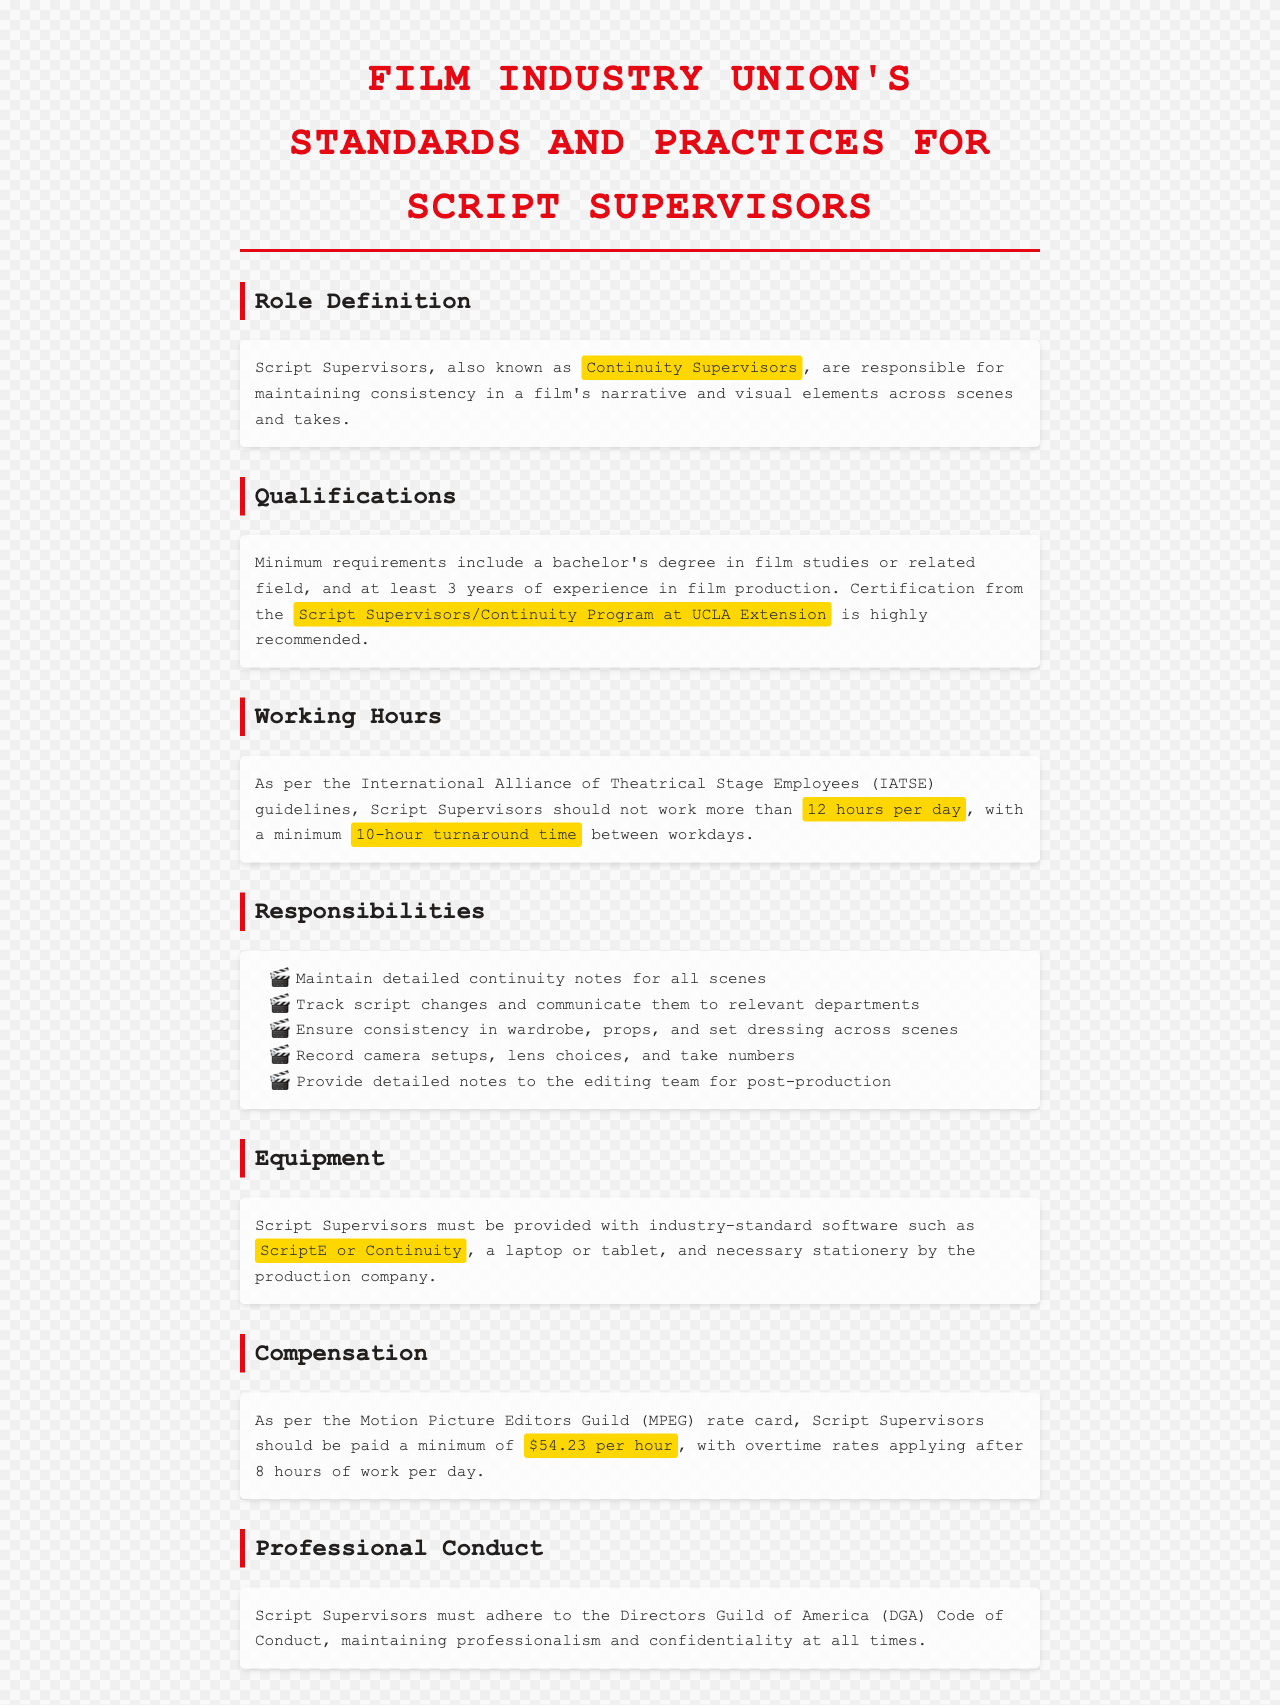What is the primary role of Script Supervisors? The document states that Script Supervisors are responsible for maintaining consistency in a film's narrative and visual elements across scenes and takes.
Answer: Maintaining consistency What is the minimum experience required for a Script Supervisor? According to the qualifications section, at least 3 years of experience in film production is required.
Answer: 3 years What is the maximum number of hours a Script Supervisor can work in one day? The document references IATSE guidelines stating that Script Supervisors should not work more than 12 hours per day.
Answer: 12 hours Which software is recommended for Script Supervisors? The equipment section mentions that Script Supervisors should use industry-standard software like ScriptE or Continuity.
Answer: ScriptE or Continuity What is the minimum hourly wage for Script Supervisors according to the MPEG rate card? The compensation section specifies that Script Supervisors should be paid a minimum of $54.23 per hour.
Answer: $54.23 per hour What must Script Supervisors adhere to for professional conduct? The document states that Script Supervisors must adhere to the Directors Guild of America (DGA) Code of Conduct.
Answer: DGA Code of Conduct What is the suggested turnaround time between workdays for Script Supervisors? The document indicates a minimum 10-hour turnaround time between workdays as per IATSE guidelines.
Answer: 10-hour turnaround time What kind of degree is recommended for Script Supervisors? The qualifications section mentions that a bachelor's degree in film studies or a related field is required.
Answer: Bachelor's degree in film studies What type of notes must Script Supervisors maintain? The responsibilities section specifies that they must maintain detailed continuity notes for all scenes.
Answer: Detailed continuity notes 